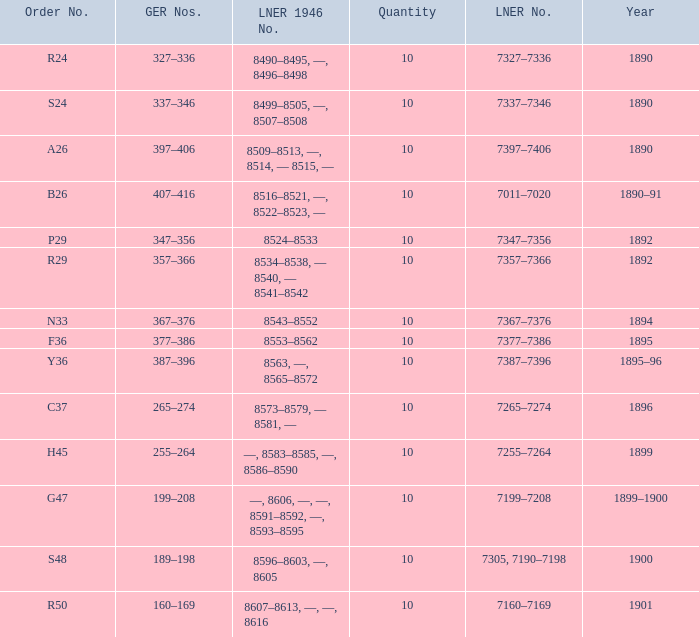What is order S24's LNER 1946 number? 8499–8505, —, 8507–8508. 